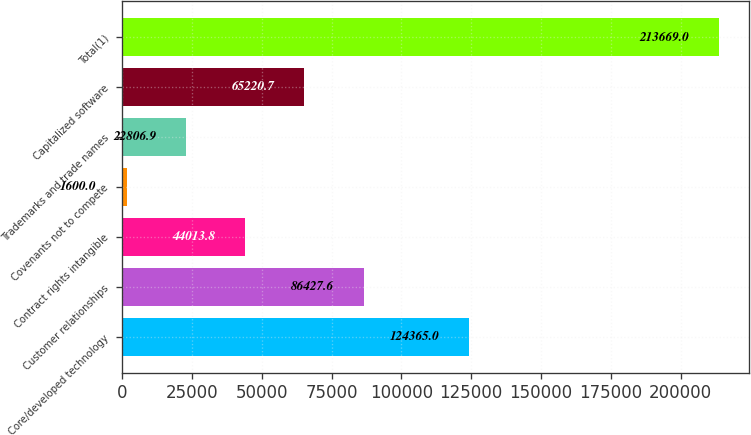<chart> <loc_0><loc_0><loc_500><loc_500><bar_chart><fcel>Core/developed technology<fcel>Customer relationships<fcel>Contract rights intangible<fcel>Covenants not to compete<fcel>Trademarks and trade names<fcel>Capitalized software<fcel>Total(1)<nl><fcel>124365<fcel>86427.6<fcel>44013.8<fcel>1600<fcel>22806.9<fcel>65220.7<fcel>213669<nl></chart> 